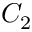<formula> <loc_0><loc_0><loc_500><loc_500>C _ { 2 }</formula> 